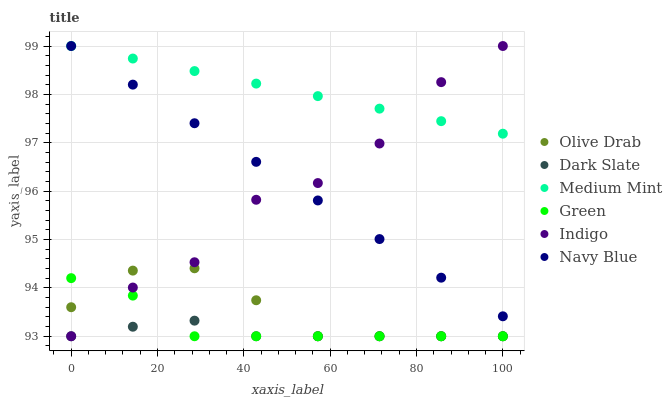Does Dark Slate have the minimum area under the curve?
Answer yes or no. Yes. Does Medium Mint have the maximum area under the curve?
Answer yes or no. Yes. Does Indigo have the minimum area under the curve?
Answer yes or no. No. Does Indigo have the maximum area under the curve?
Answer yes or no. No. Is Navy Blue the smoothest?
Answer yes or no. Yes. Is Indigo the roughest?
Answer yes or no. Yes. Is Indigo the smoothest?
Answer yes or no. No. Is Navy Blue the roughest?
Answer yes or no. No. Does Indigo have the lowest value?
Answer yes or no. Yes. Does Navy Blue have the lowest value?
Answer yes or no. No. Does Navy Blue have the highest value?
Answer yes or no. Yes. Does Dark Slate have the highest value?
Answer yes or no. No. Is Green less than Medium Mint?
Answer yes or no. Yes. Is Medium Mint greater than Olive Drab?
Answer yes or no. Yes. Does Green intersect Indigo?
Answer yes or no. Yes. Is Green less than Indigo?
Answer yes or no. No. Is Green greater than Indigo?
Answer yes or no. No. Does Green intersect Medium Mint?
Answer yes or no. No. 